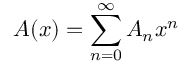Convert formula to latex. <formula><loc_0><loc_0><loc_500><loc_500>A ( x ) = \sum _ { n = 0 } ^ { \infty } A _ { n } x ^ { n }</formula> 